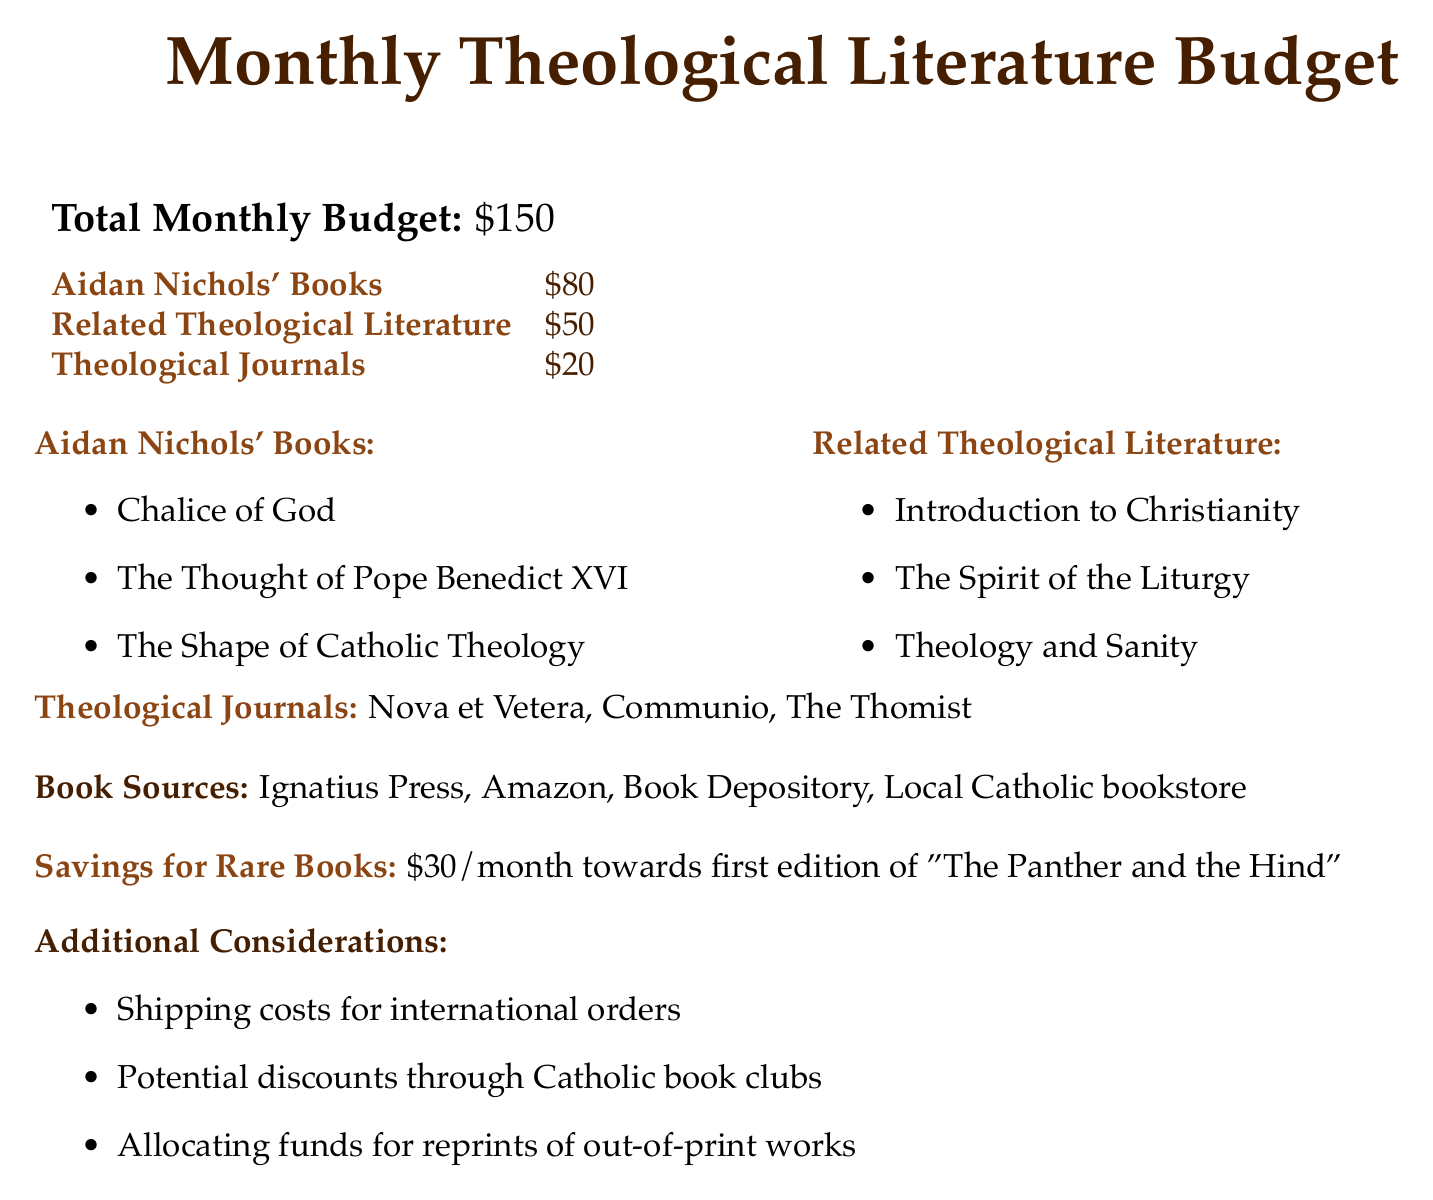What is the total monthly budget? The total monthly budget is provided at the beginning of the document and states the overall amount allocated for literature purchase.
Answer: $150 How much is allocated for Aidan Nichols' books? The budget specifically mentions the amount set aside for purchasing Aidan Nichols' books.
Answer: $80 What literature is included under Related Theological Literature? The section lists specific titles categorized as related theological literature, showcasing important writings.
Answer: Introduction to Christianity, The Spirit of the Liturgy, Theology and Sanity How much money is saved monthly for rare books? The document outlines specific savings dedicated each month toward acquiring rare books.
Answer: $30/month Which theological journals are mentioned? This question centers on identifying particular journals that are included in the budget.
Answer: Nova et Vetera, Communio, The Thomist What is the budget allocation for Theological Journals? The specified budget allocation for theological journals is noted explicitly in the financial plan.
Answer: $20 What book sources are listed? This question seeks to find the various sources indicated for purchasing books and literature within the document.
Answer: Ignatius Press, Amazon, Book Depository, Local Catholic bookstore What is the first edition title being saved for? The document mentions a specific book title that the savings are aiming to purchase in its first edition.
Answer: The Panther and the Hind Are there any considerations for international orders? The document includes a section that addresses additional factors affecting the budget, including specific shipping considerations.
Answer: Shipping costs for international orders 